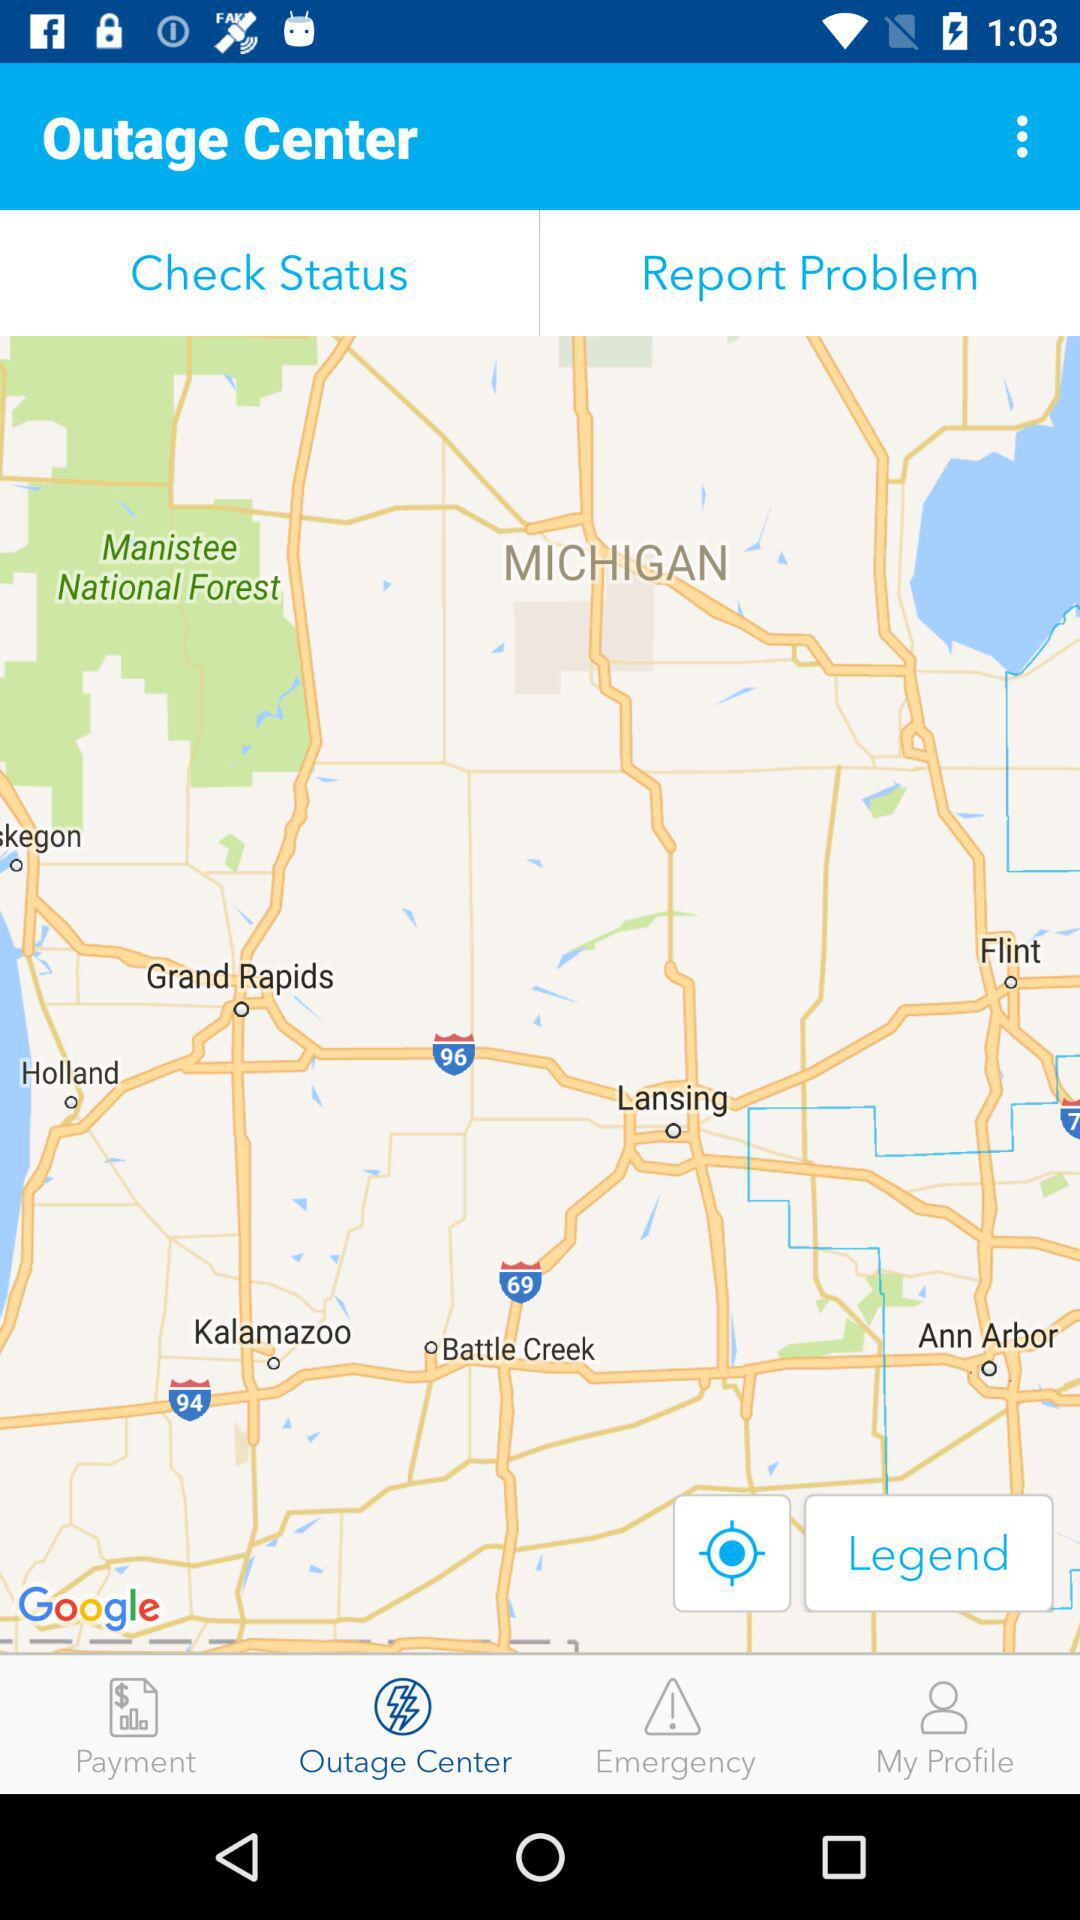Which tab is selected? The tab "Outage Center" is selected. 